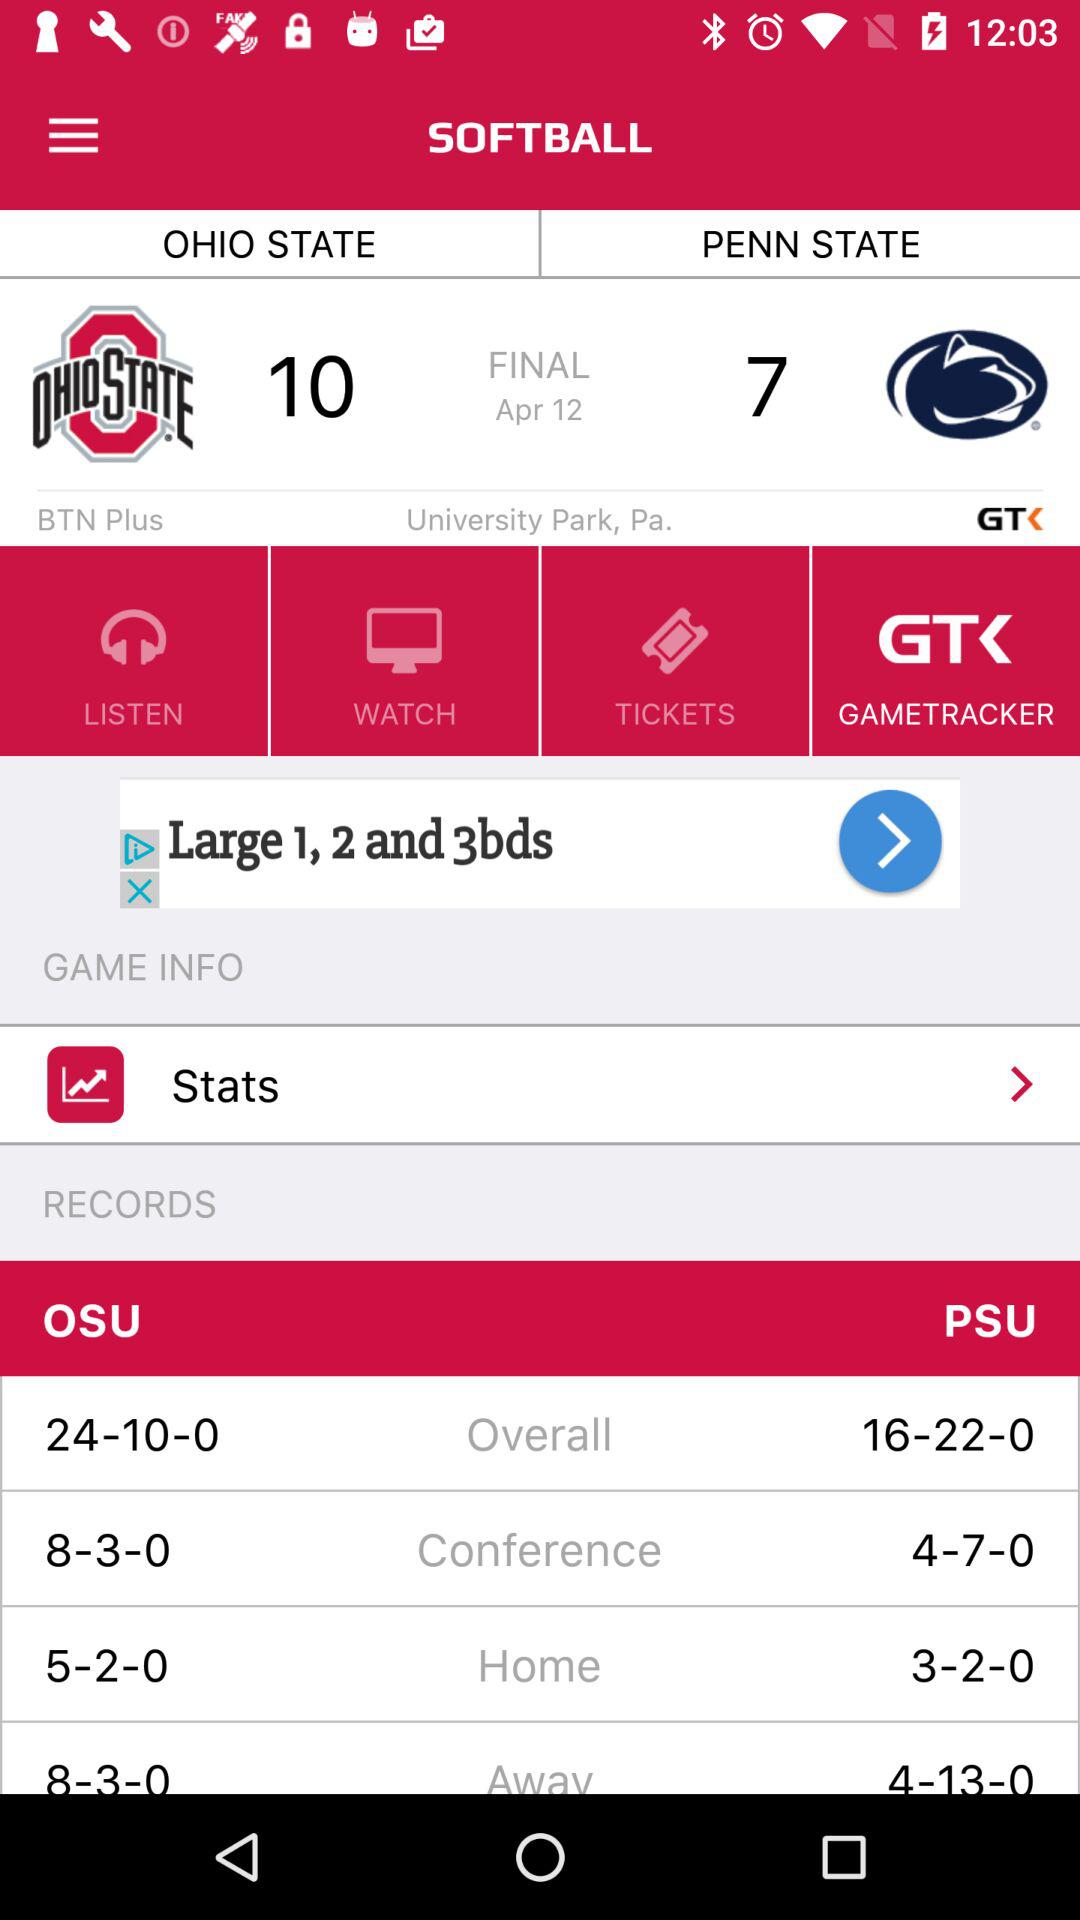When was the match held? The match was held on April 12. 